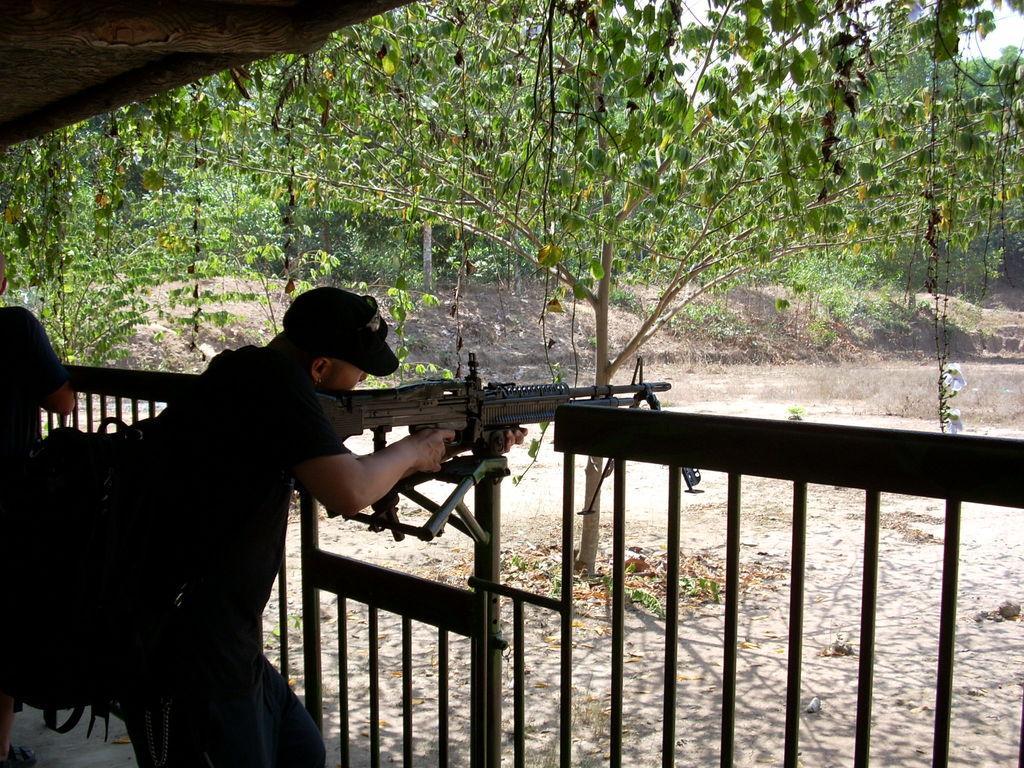How would you summarize this image in a sentence or two? In this image I can see two persons are standing and in the front I can see one man is holding a gun. I can see he is carrying a bag and he is wearing a cap. In the background I can see number of trees and in the front I can see railing. 